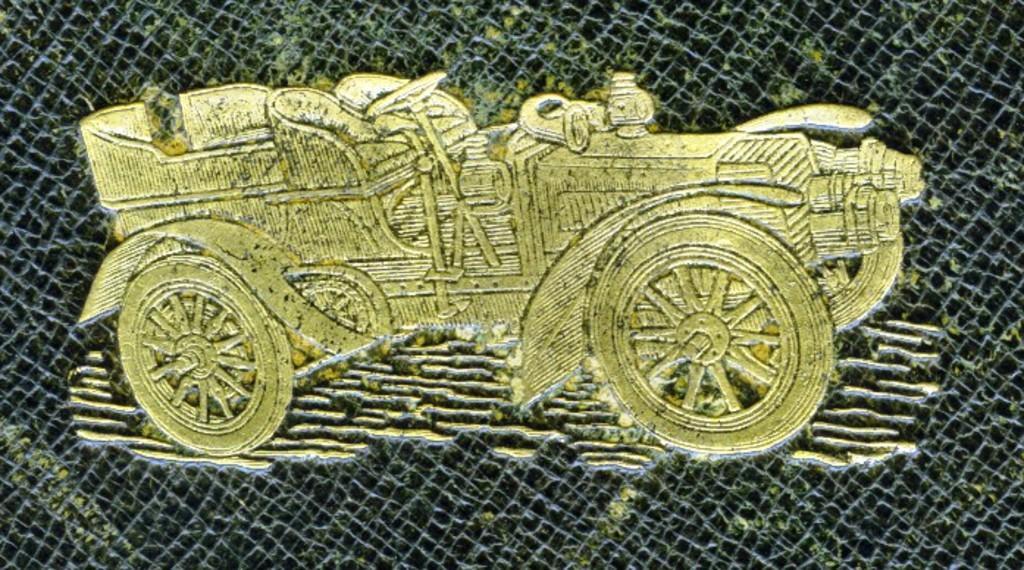Could you give a brief overview of what you see in this image? In this picture I can see there is a image of a car and it is printed on a black color surface, it is in golden color. 